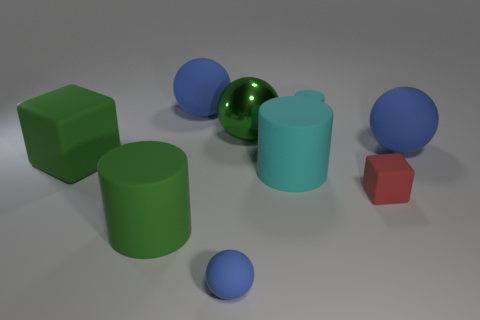Is the color of the large shiny sphere the same as the small sphere?
Your response must be concise. No. What is the material of the cyan thing that is in front of the matte cube that is left of the big cyan rubber thing?
Your response must be concise. Rubber. There is a green object that is the same shape as the tiny red thing; what is it made of?
Your answer should be compact. Rubber. There is a large blue sphere to the right of the cyan rubber thing that is behind the big cyan cylinder; are there any small cylinders on the right side of it?
Your answer should be compact. No. What number of other objects are there of the same color as the small matte block?
Give a very brief answer. 0. What number of cylinders are both in front of the green block and behind the big green cylinder?
Provide a succinct answer. 1. There is a red object; what shape is it?
Offer a terse response. Cube. What number of other things are there of the same material as the small cyan object
Offer a terse response. 7. There is a ball in front of the big blue object that is right of the large green metal object that is to the right of the big green cube; what is its color?
Offer a very short reply. Blue. There is a cyan cylinder that is the same size as the green ball; what material is it?
Your answer should be compact. Rubber. 